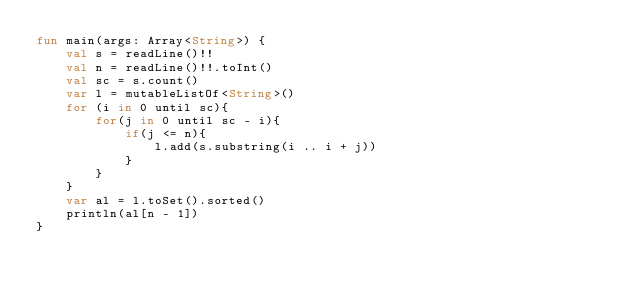<code> <loc_0><loc_0><loc_500><loc_500><_Kotlin_>fun main(args: Array<String>) {
    val s = readLine()!!
    val n = readLine()!!.toInt()
    val sc = s.count()
    var l = mutableListOf<String>()
    for (i in 0 until sc){
        for(j in 0 until sc - i){
            if(j <= n){
                l.add(s.substring(i .. i + j))
            }
        }
    }
    var al = l.toSet().sorted()
    println(al[n - 1])
}</code> 